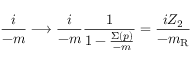Convert formula to latex. <formula><loc_0><loc_0><loc_500><loc_500>\frac { i } { \not { p } - m } \longrightarrow \frac { i } { \not { p } - m } \frac { 1 } { 1 - \frac { \Sigma ( p ) } { \not { p } - m } } = \frac { i Z _ { 2 } } { \not { p } - m _ { R } }</formula> 